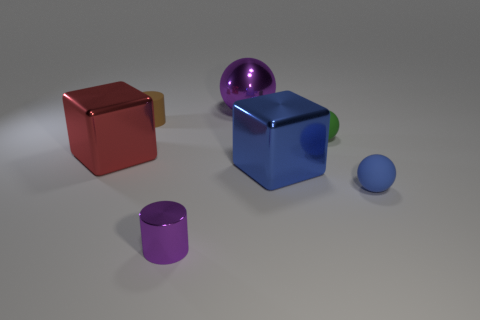What shape is the other object that is the same color as the tiny metal thing?
Provide a succinct answer. Sphere. What size is the other metallic thing that is the same color as the tiny metallic object?
Provide a succinct answer. Large. Does the metal sphere have the same color as the cylinder that is in front of the rubber cylinder?
Offer a terse response. Yes. What is the color of the metal object that is behind the red shiny cube?
Keep it short and to the point. Purple. There is a large block that is to the right of the large red metallic block; how many tiny green balls are behind it?
Offer a terse response. 1. There is a metallic cylinder; is it the same size as the matte sphere behind the tiny blue rubber thing?
Your response must be concise. Yes. Is there a matte cylinder that has the same size as the blue sphere?
Give a very brief answer. Yes. What number of objects are big green metallic objects or tiny rubber cylinders?
Ensure brevity in your answer.  1. Does the cylinder left of the tiny purple object have the same size as the green sphere that is behind the large blue block?
Keep it short and to the point. Yes. Is there another thing of the same shape as the blue shiny thing?
Offer a terse response. Yes. 